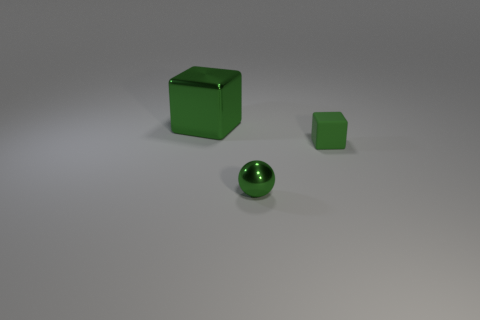There is a large thing that is the same color as the small rubber thing; what is its material?
Offer a very short reply. Metal. How many green objects are both in front of the green shiny block and behind the metallic ball?
Provide a short and direct response. 1. The other thing that is the same shape as the big green thing is what color?
Keep it short and to the point. Green. Is the number of small metal balls less than the number of red blocks?
Give a very brief answer. No. Is the size of the matte object the same as the ball that is on the left side of the tiny green matte object?
Make the answer very short. Yes. What is the color of the block that is behind the cube that is to the right of the big metallic block?
Provide a succinct answer. Green. How many things are tiny objects in front of the green matte block or objects left of the metallic sphere?
Your response must be concise. 2. Do the green rubber thing and the green metal ball have the same size?
Provide a succinct answer. Yes. Is there anything else that has the same size as the metal block?
Provide a succinct answer. No. Do the green metallic object on the left side of the tiny green metallic object and the small green object behind the small metallic thing have the same shape?
Keep it short and to the point. Yes. 